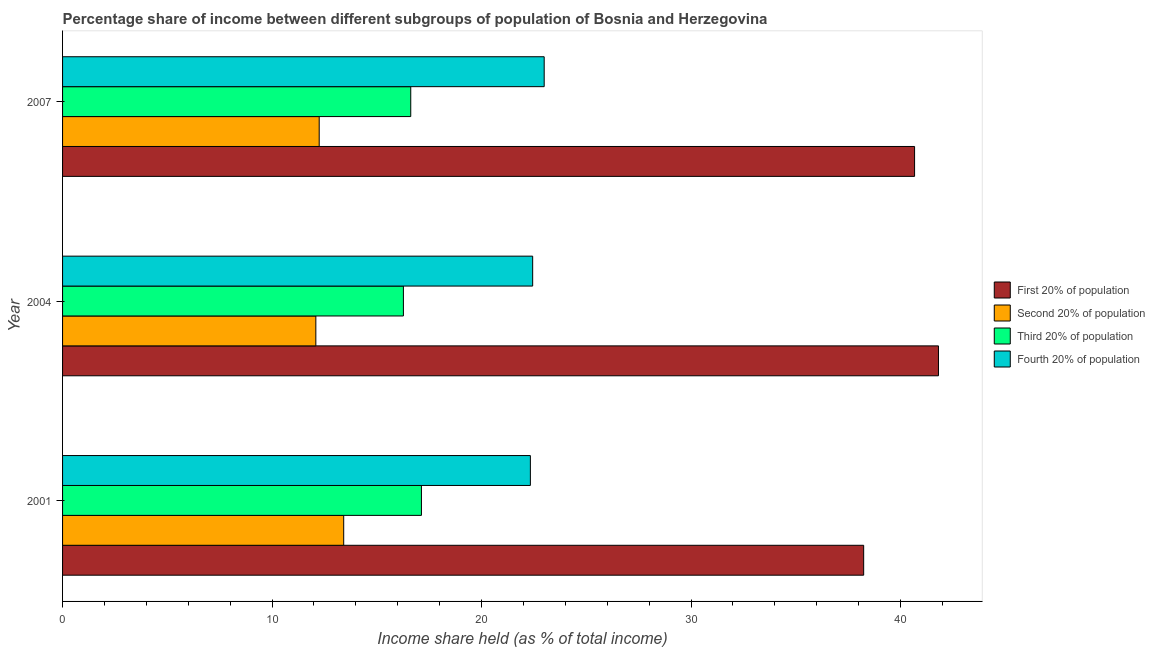Are the number of bars per tick equal to the number of legend labels?
Offer a terse response. Yes. Are the number of bars on each tick of the Y-axis equal?
Provide a succinct answer. Yes. In how many cases, is the number of bars for a given year not equal to the number of legend labels?
Give a very brief answer. 0. What is the share of the income held by fourth 20% of the population in 2001?
Make the answer very short. 22.33. Across all years, what is the maximum share of the income held by fourth 20% of the population?
Keep it short and to the point. 22.99. Across all years, what is the minimum share of the income held by second 20% of the population?
Provide a short and direct response. 12.09. In which year was the share of the income held by first 20% of the population maximum?
Make the answer very short. 2004. In which year was the share of the income held by third 20% of the population minimum?
Offer a very short reply. 2004. What is the total share of the income held by first 20% of the population in the graph?
Ensure brevity in your answer.  120.72. What is the difference between the share of the income held by first 20% of the population in 2001 and that in 2004?
Provide a short and direct response. -3.57. What is the difference between the share of the income held by fourth 20% of the population in 2007 and the share of the income held by second 20% of the population in 2001?
Keep it short and to the point. 9.57. What is the average share of the income held by third 20% of the population per year?
Make the answer very short. 16.67. In the year 2001, what is the difference between the share of the income held by fourth 20% of the population and share of the income held by second 20% of the population?
Make the answer very short. 8.91. In how many years, is the share of the income held by second 20% of the population greater than 18 %?
Provide a succinct answer. 0. What is the ratio of the share of the income held by fourth 20% of the population in 2001 to that in 2007?
Your answer should be compact. 0.97. Is the difference between the share of the income held by third 20% of the population in 2001 and 2007 greater than the difference between the share of the income held by first 20% of the population in 2001 and 2007?
Your response must be concise. Yes. What is the difference between the highest and the second highest share of the income held by fourth 20% of the population?
Provide a succinct answer. 0.55. What is the difference between the highest and the lowest share of the income held by first 20% of the population?
Your answer should be very brief. 3.57. In how many years, is the share of the income held by third 20% of the population greater than the average share of the income held by third 20% of the population taken over all years?
Ensure brevity in your answer.  1. Is the sum of the share of the income held by second 20% of the population in 2004 and 2007 greater than the maximum share of the income held by fourth 20% of the population across all years?
Provide a succinct answer. Yes. Is it the case that in every year, the sum of the share of the income held by fourth 20% of the population and share of the income held by third 20% of the population is greater than the sum of share of the income held by second 20% of the population and share of the income held by first 20% of the population?
Offer a terse response. No. What does the 3rd bar from the top in 2001 represents?
Your answer should be compact. Second 20% of population. What does the 2nd bar from the bottom in 2001 represents?
Your answer should be very brief. Second 20% of population. Is it the case that in every year, the sum of the share of the income held by first 20% of the population and share of the income held by second 20% of the population is greater than the share of the income held by third 20% of the population?
Ensure brevity in your answer.  Yes. Are all the bars in the graph horizontal?
Make the answer very short. Yes. What is the difference between two consecutive major ticks on the X-axis?
Provide a succinct answer. 10. Does the graph contain any zero values?
Ensure brevity in your answer.  No. Does the graph contain grids?
Your response must be concise. No. What is the title of the graph?
Offer a terse response. Percentage share of income between different subgroups of population of Bosnia and Herzegovina. What is the label or title of the X-axis?
Keep it short and to the point. Income share held (as % of total income). What is the Income share held (as % of total income) of First 20% of population in 2001?
Ensure brevity in your answer.  38.24. What is the Income share held (as % of total income) in Second 20% of population in 2001?
Ensure brevity in your answer.  13.42. What is the Income share held (as % of total income) in Third 20% of population in 2001?
Keep it short and to the point. 17.13. What is the Income share held (as % of total income) in Fourth 20% of population in 2001?
Make the answer very short. 22.33. What is the Income share held (as % of total income) of First 20% of population in 2004?
Provide a succinct answer. 41.81. What is the Income share held (as % of total income) in Second 20% of population in 2004?
Ensure brevity in your answer.  12.09. What is the Income share held (as % of total income) in Third 20% of population in 2004?
Your answer should be compact. 16.27. What is the Income share held (as % of total income) of Fourth 20% of population in 2004?
Offer a very short reply. 22.44. What is the Income share held (as % of total income) in First 20% of population in 2007?
Give a very brief answer. 40.67. What is the Income share held (as % of total income) in Second 20% of population in 2007?
Ensure brevity in your answer.  12.25. What is the Income share held (as % of total income) in Third 20% of population in 2007?
Offer a very short reply. 16.62. What is the Income share held (as % of total income) of Fourth 20% of population in 2007?
Provide a short and direct response. 22.99. Across all years, what is the maximum Income share held (as % of total income) in First 20% of population?
Give a very brief answer. 41.81. Across all years, what is the maximum Income share held (as % of total income) of Second 20% of population?
Offer a terse response. 13.42. Across all years, what is the maximum Income share held (as % of total income) in Third 20% of population?
Provide a succinct answer. 17.13. Across all years, what is the maximum Income share held (as % of total income) in Fourth 20% of population?
Provide a succinct answer. 22.99. Across all years, what is the minimum Income share held (as % of total income) of First 20% of population?
Offer a very short reply. 38.24. Across all years, what is the minimum Income share held (as % of total income) in Second 20% of population?
Make the answer very short. 12.09. Across all years, what is the minimum Income share held (as % of total income) of Third 20% of population?
Offer a very short reply. 16.27. Across all years, what is the minimum Income share held (as % of total income) of Fourth 20% of population?
Give a very brief answer. 22.33. What is the total Income share held (as % of total income) in First 20% of population in the graph?
Provide a short and direct response. 120.72. What is the total Income share held (as % of total income) in Second 20% of population in the graph?
Give a very brief answer. 37.76. What is the total Income share held (as % of total income) in Third 20% of population in the graph?
Give a very brief answer. 50.02. What is the total Income share held (as % of total income) of Fourth 20% of population in the graph?
Your answer should be very brief. 67.76. What is the difference between the Income share held (as % of total income) of First 20% of population in 2001 and that in 2004?
Provide a short and direct response. -3.57. What is the difference between the Income share held (as % of total income) of Second 20% of population in 2001 and that in 2004?
Your response must be concise. 1.33. What is the difference between the Income share held (as % of total income) in Third 20% of population in 2001 and that in 2004?
Offer a terse response. 0.86. What is the difference between the Income share held (as % of total income) in Fourth 20% of population in 2001 and that in 2004?
Ensure brevity in your answer.  -0.11. What is the difference between the Income share held (as % of total income) of First 20% of population in 2001 and that in 2007?
Offer a terse response. -2.43. What is the difference between the Income share held (as % of total income) of Second 20% of population in 2001 and that in 2007?
Provide a succinct answer. 1.17. What is the difference between the Income share held (as % of total income) in Third 20% of population in 2001 and that in 2007?
Ensure brevity in your answer.  0.51. What is the difference between the Income share held (as % of total income) in Fourth 20% of population in 2001 and that in 2007?
Your response must be concise. -0.66. What is the difference between the Income share held (as % of total income) in First 20% of population in 2004 and that in 2007?
Make the answer very short. 1.14. What is the difference between the Income share held (as % of total income) of Second 20% of population in 2004 and that in 2007?
Your answer should be compact. -0.16. What is the difference between the Income share held (as % of total income) in Third 20% of population in 2004 and that in 2007?
Offer a terse response. -0.35. What is the difference between the Income share held (as % of total income) of Fourth 20% of population in 2004 and that in 2007?
Provide a short and direct response. -0.55. What is the difference between the Income share held (as % of total income) of First 20% of population in 2001 and the Income share held (as % of total income) of Second 20% of population in 2004?
Offer a terse response. 26.15. What is the difference between the Income share held (as % of total income) in First 20% of population in 2001 and the Income share held (as % of total income) in Third 20% of population in 2004?
Offer a terse response. 21.97. What is the difference between the Income share held (as % of total income) of Second 20% of population in 2001 and the Income share held (as % of total income) of Third 20% of population in 2004?
Ensure brevity in your answer.  -2.85. What is the difference between the Income share held (as % of total income) of Second 20% of population in 2001 and the Income share held (as % of total income) of Fourth 20% of population in 2004?
Keep it short and to the point. -9.02. What is the difference between the Income share held (as % of total income) of Third 20% of population in 2001 and the Income share held (as % of total income) of Fourth 20% of population in 2004?
Offer a very short reply. -5.31. What is the difference between the Income share held (as % of total income) of First 20% of population in 2001 and the Income share held (as % of total income) of Second 20% of population in 2007?
Your response must be concise. 25.99. What is the difference between the Income share held (as % of total income) in First 20% of population in 2001 and the Income share held (as % of total income) in Third 20% of population in 2007?
Your response must be concise. 21.62. What is the difference between the Income share held (as % of total income) in First 20% of population in 2001 and the Income share held (as % of total income) in Fourth 20% of population in 2007?
Your answer should be very brief. 15.25. What is the difference between the Income share held (as % of total income) in Second 20% of population in 2001 and the Income share held (as % of total income) in Fourth 20% of population in 2007?
Keep it short and to the point. -9.57. What is the difference between the Income share held (as % of total income) of Third 20% of population in 2001 and the Income share held (as % of total income) of Fourth 20% of population in 2007?
Your answer should be very brief. -5.86. What is the difference between the Income share held (as % of total income) of First 20% of population in 2004 and the Income share held (as % of total income) of Second 20% of population in 2007?
Offer a terse response. 29.56. What is the difference between the Income share held (as % of total income) of First 20% of population in 2004 and the Income share held (as % of total income) of Third 20% of population in 2007?
Offer a very short reply. 25.19. What is the difference between the Income share held (as % of total income) in First 20% of population in 2004 and the Income share held (as % of total income) in Fourth 20% of population in 2007?
Your answer should be compact. 18.82. What is the difference between the Income share held (as % of total income) of Second 20% of population in 2004 and the Income share held (as % of total income) of Third 20% of population in 2007?
Offer a terse response. -4.53. What is the difference between the Income share held (as % of total income) in Second 20% of population in 2004 and the Income share held (as % of total income) in Fourth 20% of population in 2007?
Provide a short and direct response. -10.9. What is the difference between the Income share held (as % of total income) in Third 20% of population in 2004 and the Income share held (as % of total income) in Fourth 20% of population in 2007?
Provide a short and direct response. -6.72. What is the average Income share held (as % of total income) in First 20% of population per year?
Offer a very short reply. 40.24. What is the average Income share held (as % of total income) of Second 20% of population per year?
Offer a very short reply. 12.59. What is the average Income share held (as % of total income) of Third 20% of population per year?
Provide a short and direct response. 16.67. What is the average Income share held (as % of total income) of Fourth 20% of population per year?
Provide a short and direct response. 22.59. In the year 2001, what is the difference between the Income share held (as % of total income) of First 20% of population and Income share held (as % of total income) of Second 20% of population?
Your answer should be compact. 24.82. In the year 2001, what is the difference between the Income share held (as % of total income) in First 20% of population and Income share held (as % of total income) in Third 20% of population?
Offer a terse response. 21.11. In the year 2001, what is the difference between the Income share held (as % of total income) of First 20% of population and Income share held (as % of total income) of Fourth 20% of population?
Your answer should be very brief. 15.91. In the year 2001, what is the difference between the Income share held (as % of total income) in Second 20% of population and Income share held (as % of total income) in Third 20% of population?
Offer a terse response. -3.71. In the year 2001, what is the difference between the Income share held (as % of total income) of Second 20% of population and Income share held (as % of total income) of Fourth 20% of population?
Provide a short and direct response. -8.91. In the year 2004, what is the difference between the Income share held (as % of total income) of First 20% of population and Income share held (as % of total income) of Second 20% of population?
Your answer should be very brief. 29.72. In the year 2004, what is the difference between the Income share held (as % of total income) in First 20% of population and Income share held (as % of total income) in Third 20% of population?
Give a very brief answer. 25.54. In the year 2004, what is the difference between the Income share held (as % of total income) of First 20% of population and Income share held (as % of total income) of Fourth 20% of population?
Make the answer very short. 19.37. In the year 2004, what is the difference between the Income share held (as % of total income) in Second 20% of population and Income share held (as % of total income) in Third 20% of population?
Ensure brevity in your answer.  -4.18. In the year 2004, what is the difference between the Income share held (as % of total income) in Second 20% of population and Income share held (as % of total income) in Fourth 20% of population?
Ensure brevity in your answer.  -10.35. In the year 2004, what is the difference between the Income share held (as % of total income) of Third 20% of population and Income share held (as % of total income) of Fourth 20% of population?
Keep it short and to the point. -6.17. In the year 2007, what is the difference between the Income share held (as % of total income) of First 20% of population and Income share held (as % of total income) of Second 20% of population?
Make the answer very short. 28.42. In the year 2007, what is the difference between the Income share held (as % of total income) in First 20% of population and Income share held (as % of total income) in Third 20% of population?
Provide a short and direct response. 24.05. In the year 2007, what is the difference between the Income share held (as % of total income) of First 20% of population and Income share held (as % of total income) of Fourth 20% of population?
Your answer should be compact. 17.68. In the year 2007, what is the difference between the Income share held (as % of total income) in Second 20% of population and Income share held (as % of total income) in Third 20% of population?
Your answer should be compact. -4.37. In the year 2007, what is the difference between the Income share held (as % of total income) of Second 20% of population and Income share held (as % of total income) of Fourth 20% of population?
Provide a short and direct response. -10.74. In the year 2007, what is the difference between the Income share held (as % of total income) of Third 20% of population and Income share held (as % of total income) of Fourth 20% of population?
Offer a terse response. -6.37. What is the ratio of the Income share held (as % of total income) of First 20% of population in 2001 to that in 2004?
Keep it short and to the point. 0.91. What is the ratio of the Income share held (as % of total income) in Second 20% of population in 2001 to that in 2004?
Provide a short and direct response. 1.11. What is the ratio of the Income share held (as % of total income) of Third 20% of population in 2001 to that in 2004?
Your answer should be compact. 1.05. What is the ratio of the Income share held (as % of total income) of Fourth 20% of population in 2001 to that in 2004?
Offer a very short reply. 1. What is the ratio of the Income share held (as % of total income) in First 20% of population in 2001 to that in 2007?
Provide a short and direct response. 0.94. What is the ratio of the Income share held (as % of total income) in Second 20% of population in 2001 to that in 2007?
Give a very brief answer. 1.1. What is the ratio of the Income share held (as % of total income) in Third 20% of population in 2001 to that in 2007?
Your answer should be very brief. 1.03. What is the ratio of the Income share held (as % of total income) in Fourth 20% of population in 2001 to that in 2007?
Ensure brevity in your answer.  0.97. What is the ratio of the Income share held (as % of total income) in First 20% of population in 2004 to that in 2007?
Your response must be concise. 1.03. What is the ratio of the Income share held (as % of total income) of Second 20% of population in 2004 to that in 2007?
Ensure brevity in your answer.  0.99. What is the ratio of the Income share held (as % of total income) of Third 20% of population in 2004 to that in 2007?
Ensure brevity in your answer.  0.98. What is the ratio of the Income share held (as % of total income) of Fourth 20% of population in 2004 to that in 2007?
Offer a very short reply. 0.98. What is the difference between the highest and the second highest Income share held (as % of total income) of First 20% of population?
Your response must be concise. 1.14. What is the difference between the highest and the second highest Income share held (as % of total income) of Second 20% of population?
Offer a very short reply. 1.17. What is the difference between the highest and the second highest Income share held (as % of total income) of Third 20% of population?
Your answer should be very brief. 0.51. What is the difference between the highest and the second highest Income share held (as % of total income) in Fourth 20% of population?
Offer a very short reply. 0.55. What is the difference between the highest and the lowest Income share held (as % of total income) in First 20% of population?
Offer a very short reply. 3.57. What is the difference between the highest and the lowest Income share held (as % of total income) of Second 20% of population?
Your answer should be very brief. 1.33. What is the difference between the highest and the lowest Income share held (as % of total income) in Third 20% of population?
Provide a short and direct response. 0.86. What is the difference between the highest and the lowest Income share held (as % of total income) of Fourth 20% of population?
Offer a terse response. 0.66. 